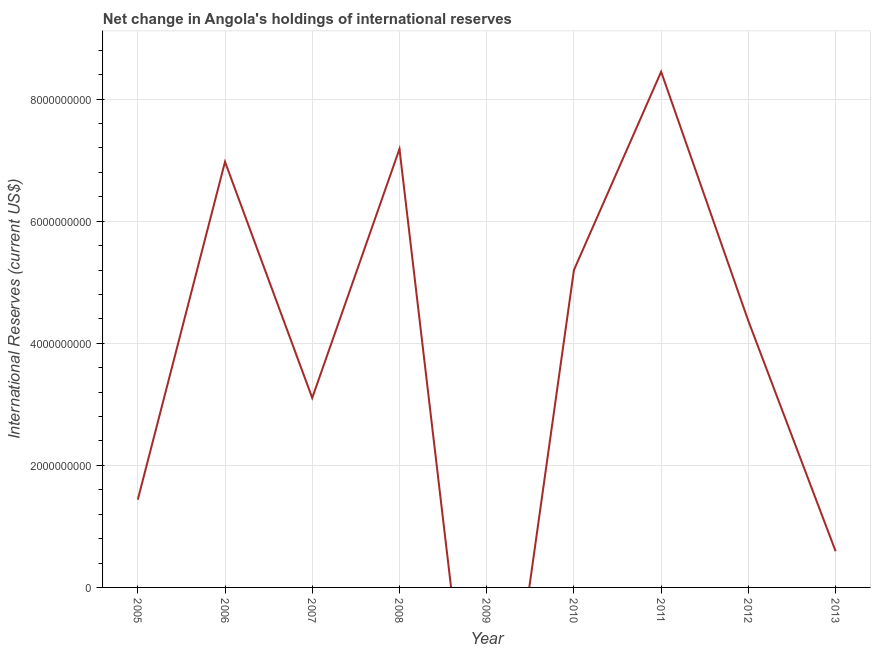What is the reserves and related items in 2010?
Your answer should be very brief. 5.20e+09. Across all years, what is the maximum reserves and related items?
Your response must be concise. 8.45e+09. In which year was the reserves and related items maximum?
Your answer should be very brief. 2011. What is the sum of the reserves and related items?
Your answer should be compact. 3.73e+1. What is the difference between the reserves and related items in 2007 and 2008?
Keep it short and to the point. -4.08e+09. What is the average reserves and related items per year?
Provide a short and direct response. 4.15e+09. What is the median reserves and related items?
Ensure brevity in your answer.  4.36e+09. In how many years, is the reserves and related items greater than 7200000000 US$?
Your answer should be compact. 1. What is the ratio of the reserves and related items in 2005 to that in 2012?
Provide a succinct answer. 0.33. Is the reserves and related items in 2011 less than that in 2013?
Ensure brevity in your answer.  No. Is the difference between the reserves and related items in 2010 and 2011 greater than the difference between any two years?
Give a very brief answer. No. What is the difference between the highest and the second highest reserves and related items?
Provide a succinct answer. 1.27e+09. What is the difference between the highest and the lowest reserves and related items?
Your answer should be compact. 8.45e+09. Does the reserves and related items monotonically increase over the years?
Your response must be concise. No. How many years are there in the graph?
Give a very brief answer. 9. What is the difference between two consecutive major ticks on the Y-axis?
Your response must be concise. 2.00e+09. Are the values on the major ticks of Y-axis written in scientific E-notation?
Your answer should be compact. No. Does the graph contain grids?
Ensure brevity in your answer.  Yes. What is the title of the graph?
Your answer should be very brief. Net change in Angola's holdings of international reserves. What is the label or title of the Y-axis?
Provide a short and direct response. International Reserves (current US$). What is the International Reserves (current US$) of 2005?
Your answer should be very brief. 1.44e+09. What is the International Reserves (current US$) in 2006?
Your response must be concise. 6.97e+09. What is the International Reserves (current US$) in 2007?
Give a very brief answer. 3.10e+09. What is the International Reserves (current US$) in 2008?
Provide a short and direct response. 7.18e+09. What is the International Reserves (current US$) of 2009?
Ensure brevity in your answer.  0. What is the International Reserves (current US$) of 2010?
Offer a very short reply. 5.20e+09. What is the International Reserves (current US$) of 2011?
Your answer should be very brief. 8.45e+09. What is the International Reserves (current US$) in 2012?
Your answer should be very brief. 4.36e+09. What is the International Reserves (current US$) of 2013?
Provide a short and direct response. 5.93e+08. What is the difference between the International Reserves (current US$) in 2005 and 2006?
Offer a terse response. -5.54e+09. What is the difference between the International Reserves (current US$) in 2005 and 2007?
Give a very brief answer. -1.67e+09. What is the difference between the International Reserves (current US$) in 2005 and 2008?
Give a very brief answer. -5.75e+09. What is the difference between the International Reserves (current US$) in 2005 and 2010?
Your answer should be very brief. -3.76e+09. What is the difference between the International Reserves (current US$) in 2005 and 2011?
Your response must be concise. -7.01e+09. What is the difference between the International Reserves (current US$) in 2005 and 2012?
Offer a terse response. -2.93e+09. What is the difference between the International Reserves (current US$) in 2005 and 2013?
Your answer should be very brief. 8.45e+08. What is the difference between the International Reserves (current US$) in 2006 and 2007?
Provide a short and direct response. 3.87e+09. What is the difference between the International Reserves (current US$) in 2006 and 2008?
Ensure brevity in your answer.  -2.10e+08. What is the difference between the International Reserves (current US$) in 2006 and 2010?
Provide a succinct answer. 1.77e+09. What is the difference between the International Reserves (current US$) in 2006 and 2011?
Your response must be concise. -1.48e+09. What is the difference between the International Reserves (current US$) in 2006 and 2012?
Offer a terse response. 2.61e+09. What is the difference between the International Reserves (current US$) in 2006 and 2013?
Your answer should be compact. 6.38e+09. What is the difference between the International Reserves (current US$) in 2007 and 2008?
Your answer should be compact. -4.08e+09. What is the difference between the International Reserves (current US$) in 2007 and 2010?
Offer a very short reply. -2.09e+09. What is the difference between the International Reserves (current US$) in 2007 and 2011?
Keep it short and to the point. -5.34e+09. What is the difference between the International Reserves (current US$) in 2007 and 2012?
Keep it short and to the point. -1.26e+09. What is the difference between the International Reserves (current US$) in 2007 and 2013?
Give a very brief answer. 2.51e+09. What is the difference between the International Reserves (current US$) in 2008 and 2010?
Provide a succinct answer. 1.98e+09. What is the difference between the International Reserves (current US$) in 2008 and 2011?
Give a very brief answer. -1.27e+09. What is the difference between the International Reserves (current US$) in 2008 and 2012?
Make the answer very short. 2.82e+09. What is the difference between the International Reserves (current US$) in 2008 and 2013?
Give a very brief answer. 6.59e+09. What is the difference between the International Reserves (current US$) in 2010 and 2011?
Your answer should be compact. -3.25e+09. What is the difference between the International Reserves (current US$) in 2010 and 2012?
Provide a short and direct response. 8.35e+08. What is the difference between the International Reserves (current US$) in 2010 and 2013?
Make the answer very short. 4.61e+09. What is the difference between the International Reserves (current US$) in 2011 and 2012?
Give a very brief answer. 4.08e+09. What is the difference between the International Reserves (current US$) in 2011 and 2013?
Your answer should be very brief. 7.86e+09. What is the difference between the International Reserves (current US$) in 2012 and 2013?
Your response must be concise. 3.77e+09. What is the ratio of the International Reserves (current US$) in 2005 to that in 2006?
Make the answer very short. 0.21. What is the ratio of the International Reserves (current US$) in 2005 to that in 2007?
Give a very brief answer. 0.46. What is the ratio of the International Reserves (current US$) in 2005 to that in 2010?
Provide a succinct answer. 0.28. What is the ratio of the International Reserves (current US$) in 2005 to that in 2011?
Offer a terse response. 0.17. What is the ratio of the International Reserves (current US$) in 2005 to that in 2012?
Your answer should be very brief. 0.33. What is the ratio of the International Reserves (current US$) in 2005 to that in 2013?
Make the answer very short. 2.43. What is the ratio of the International Reserves (current US$) in 2006 to that in 2007?
Your response must be concise. 2.25. What is the ratio of the International Reserves (current US$) in 2006 to that in 2008?
Provide a short and direct response. 0.97. What is the ratio of the International Reserves (current US$) in 2006 to that in 2010?
Keep it short and to the point. 1.34. What is the ratio of the International Reserves (current US$) in 2006 to that in 2011?
Make the answer very short. 0.82. What is the ratio of the International Reserves (current US$) in 2006 to that in 2012?
Offer a very short reply. 1.6. What is the ratio of the International Reserves (current US$) in 2006 to that in 2013?
Provide a short and direct response. 11.77. What is the ratio of the International Reserves (current US$) in 2007 to that in 2008?
Make the answer very short. 0.43. What is the ratio of the International Reserves (current US$) in 2007 to that in 2010?
Offer a very short reply. 0.6. What is the ratio of the International Reserves (current US$) in 2007 to that in 2011?
Offer a very short reply. 0.37. What is the ratio of the International Reserves (current US$) in 2007 to that in 2012?
Offer a very short reply. 0.71. What is the ratio of the International Reserves (current US$) in 2007 to that in 2013?
Your response must be concise. 5.24. What is the ratio of the International Reserves (current US$) in 2008 to that in 2010?
Your answer should be very brief. 1.38. What is the ratio of the International Reserves (current US$) in 2008 to that in 2012?
Keep it short and to the point. 1.65. What is the ratio of the International Reserves (current US$) in 2008 to that in 2013?
Offer a terse response. 12.12. What is the ratio of the International Reserves (current US$) in 2010 to that in 2011?
Keep it short and to the point. 0.61. What is the ratio of the International Reserves (current US$) in 2010 to that in 2012?
Offer a terse response. 1.19. What is the ratio of the International Reserves (current US$) in 2010 to that in 2013?
Give a very brief answer. 8.77. What is the ratio of the International Reserves (current US$) in 2011 to that in 2012?
Provide a short and direct response. 1.94. What is the ratio of the International Reserves (current US$) in 2011 to that in 2013?
Offer a very short reply. 14.26. What is the ratio of the International Reserves (current US$) in 2012 to that in 2013?
Give a very brief answer. 7.37. 